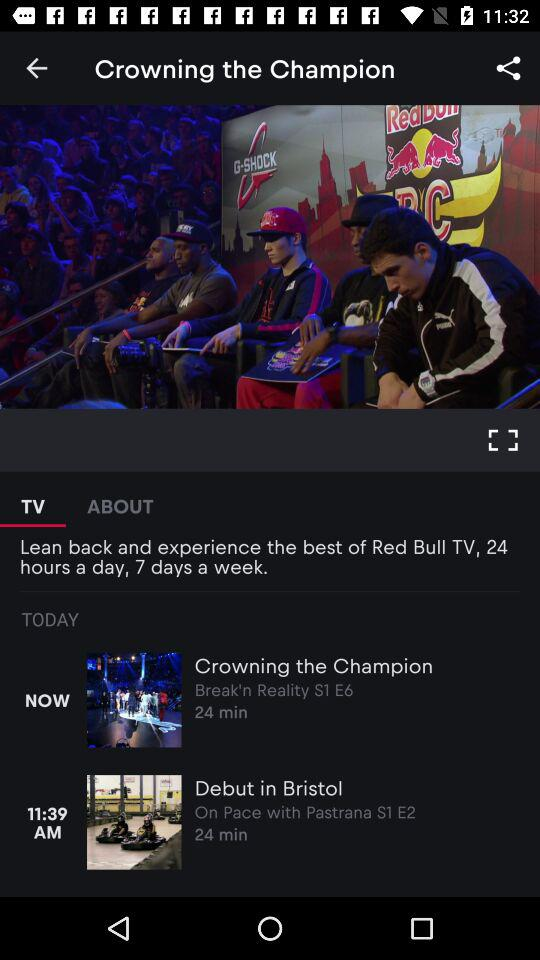What video will be played at 11:39 AM? The video "Debut in Bristol" will be played at 11:39 AM. 